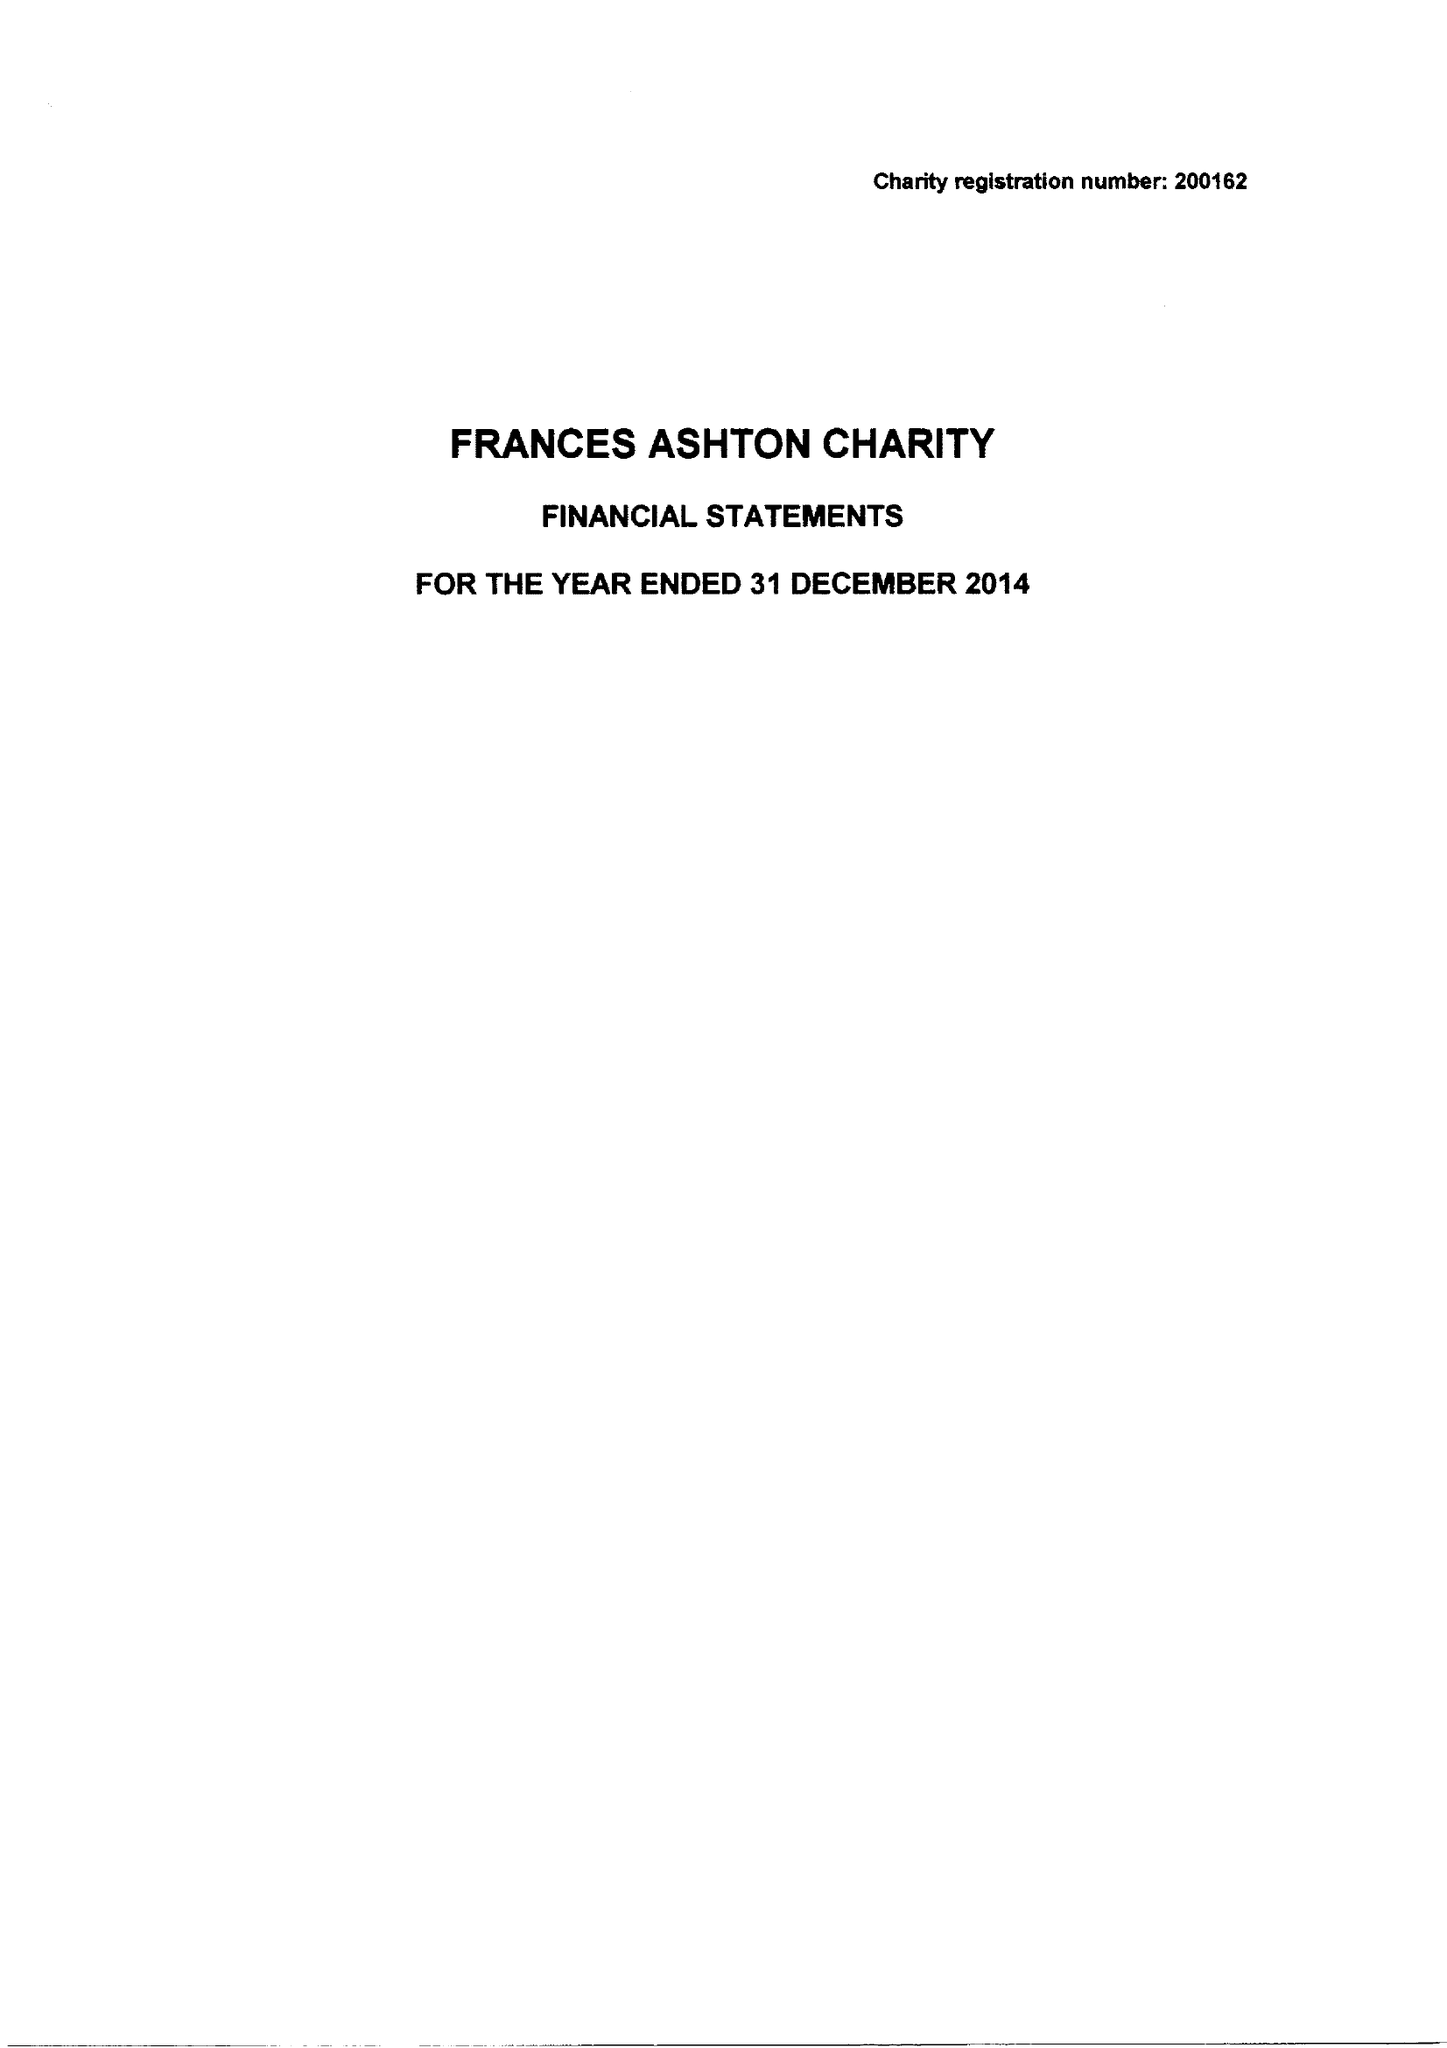What is the value for the charity_number?
Answer the question using a single word or phrase. 200162 